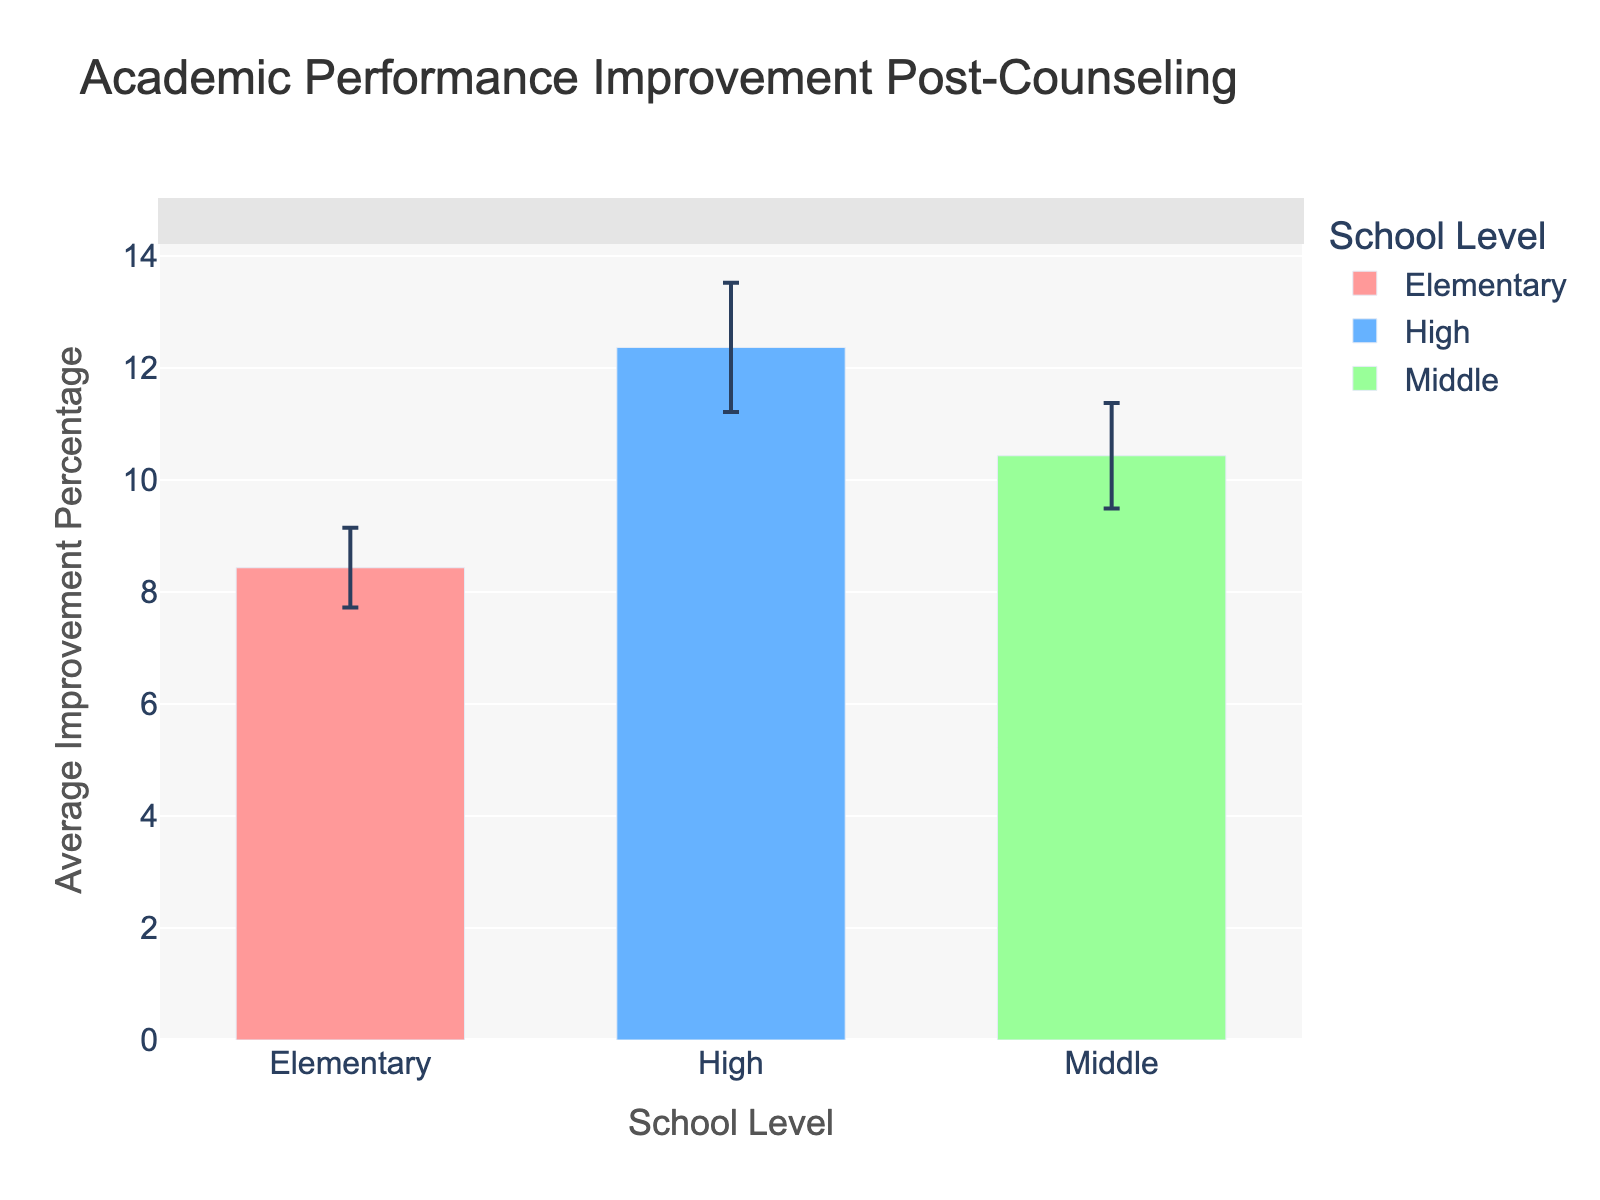What is the title of the figure? The title is usually located at the top of the figure, where it summarizes the content. Here, it reads "Academic Performance Improvement Post-Counseling".
Answer: Academic Performance Improvement Post-Counseling What school level shows the highest average improvement percentage? From the data shown in the bars, the level with the highest bar corresponds to "High School". The height of the bar indicates the average improvement percentage.
Answer: High School What is the average improvement percentage for Middle School students? The Middle School bar has a specific height, which correlates with a numerical value on the Y-axis. From the figure, this value represents the average improvement percentage.
Answer: Approximately 10.43% Which school level has the smallest error bar? The error bars represent the uncertainty or standard error of the mean. Visually, the shortest error bar indicates the smallest uncertainty. By comparing the heights, Elementary School has the shortest error bar.
Answer: Elementary School How does the average improvement percentage for Elementary School compare to that for High School? The heights of the "Elementary School" and "High School" bars are compared. The "High School" bar is noticeably taller than the "Elementary School" bar, indicating a higher average.
Answer: High School is higher What is the approximate range of average improvement percentages among all school levels? The range is between the smallest and largest average improvement percentages. By looking at each bar's starting and ending points on the Y-axis: Elementary (around 8.43%), Middle (around 10.43%), and High (around 12.37%). The range, therefore, spans from about 8.43% to about 12.37%.
Answer: 8.43% to 12.37% How does the average improvement percentage of Middle School students compare to the other two school levels? Calculate the difference between Middle School and the other levels: Middle School to Elementary (10.43% - 8.43% ≈ 2%), and Middle School to High School (12.37% - 10.43% ≈ 1.94%). Middle is higher than Elementary by about 2% and lower than High by about 1.94%.
Answer: Higher than Elementary, lower than High What is the error bar length for High School's average improvement percentage? The error bar length represents the uncertainty in the average. For High School, the top of the error bar is slightly above the bar's height. This length indicates the uncertainty range, calculated earlier. Specifically, it shows around 0.63%.
Answer: Approximately 0.63% What visual feature helps to differentiate the school levels in the plot? Different colors are used to separate each level visually. These colors make it easier to distinguish the bars representing Elementary, Middle, and High School.
Answer: Different colors Which school level has the greatest variability in average improvement percentage? Variability is seen through the length of the error bars. The longer the error bars, the greater the variability. High School has the longest error bars compared to other levels.
Answer: High School 